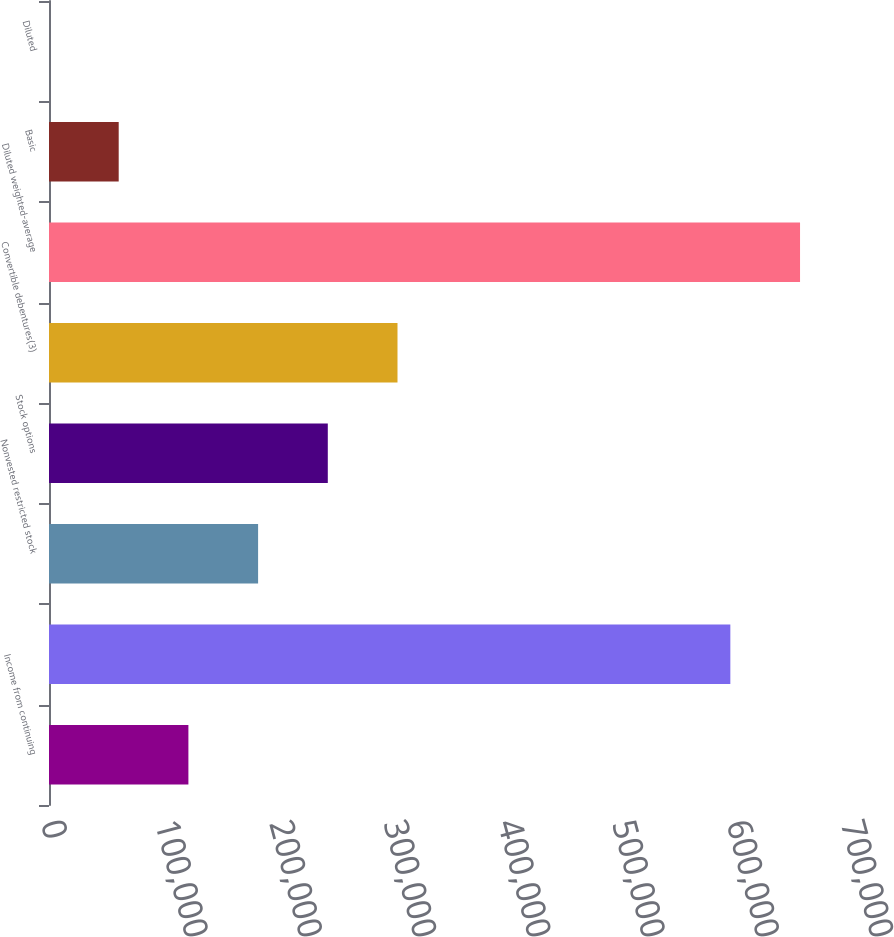<chart> <loc_0><loc_0><loc_500><loc_500><bar_chart><fcel>Income from continuing<fcel>Unnamed: 1<fcel>Nonvested restricted stock<fcel>Stock options<fcel>Convertible debentures(3)<fcel>Diluted weighted-average<fcel>Basic<fcel>Diluted<nl><fcel>121974<fcel>596174<fcel>182961<fcel>243947<fcel>304934<fcel>657160<fcel>60987.9<fcel>1.4<nl></chart> 